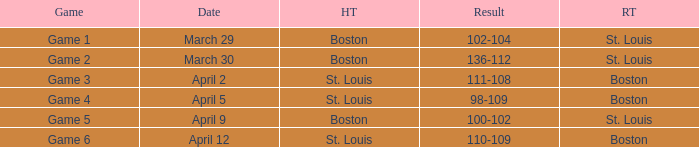What is the number of the game on march 30? Game 2. 